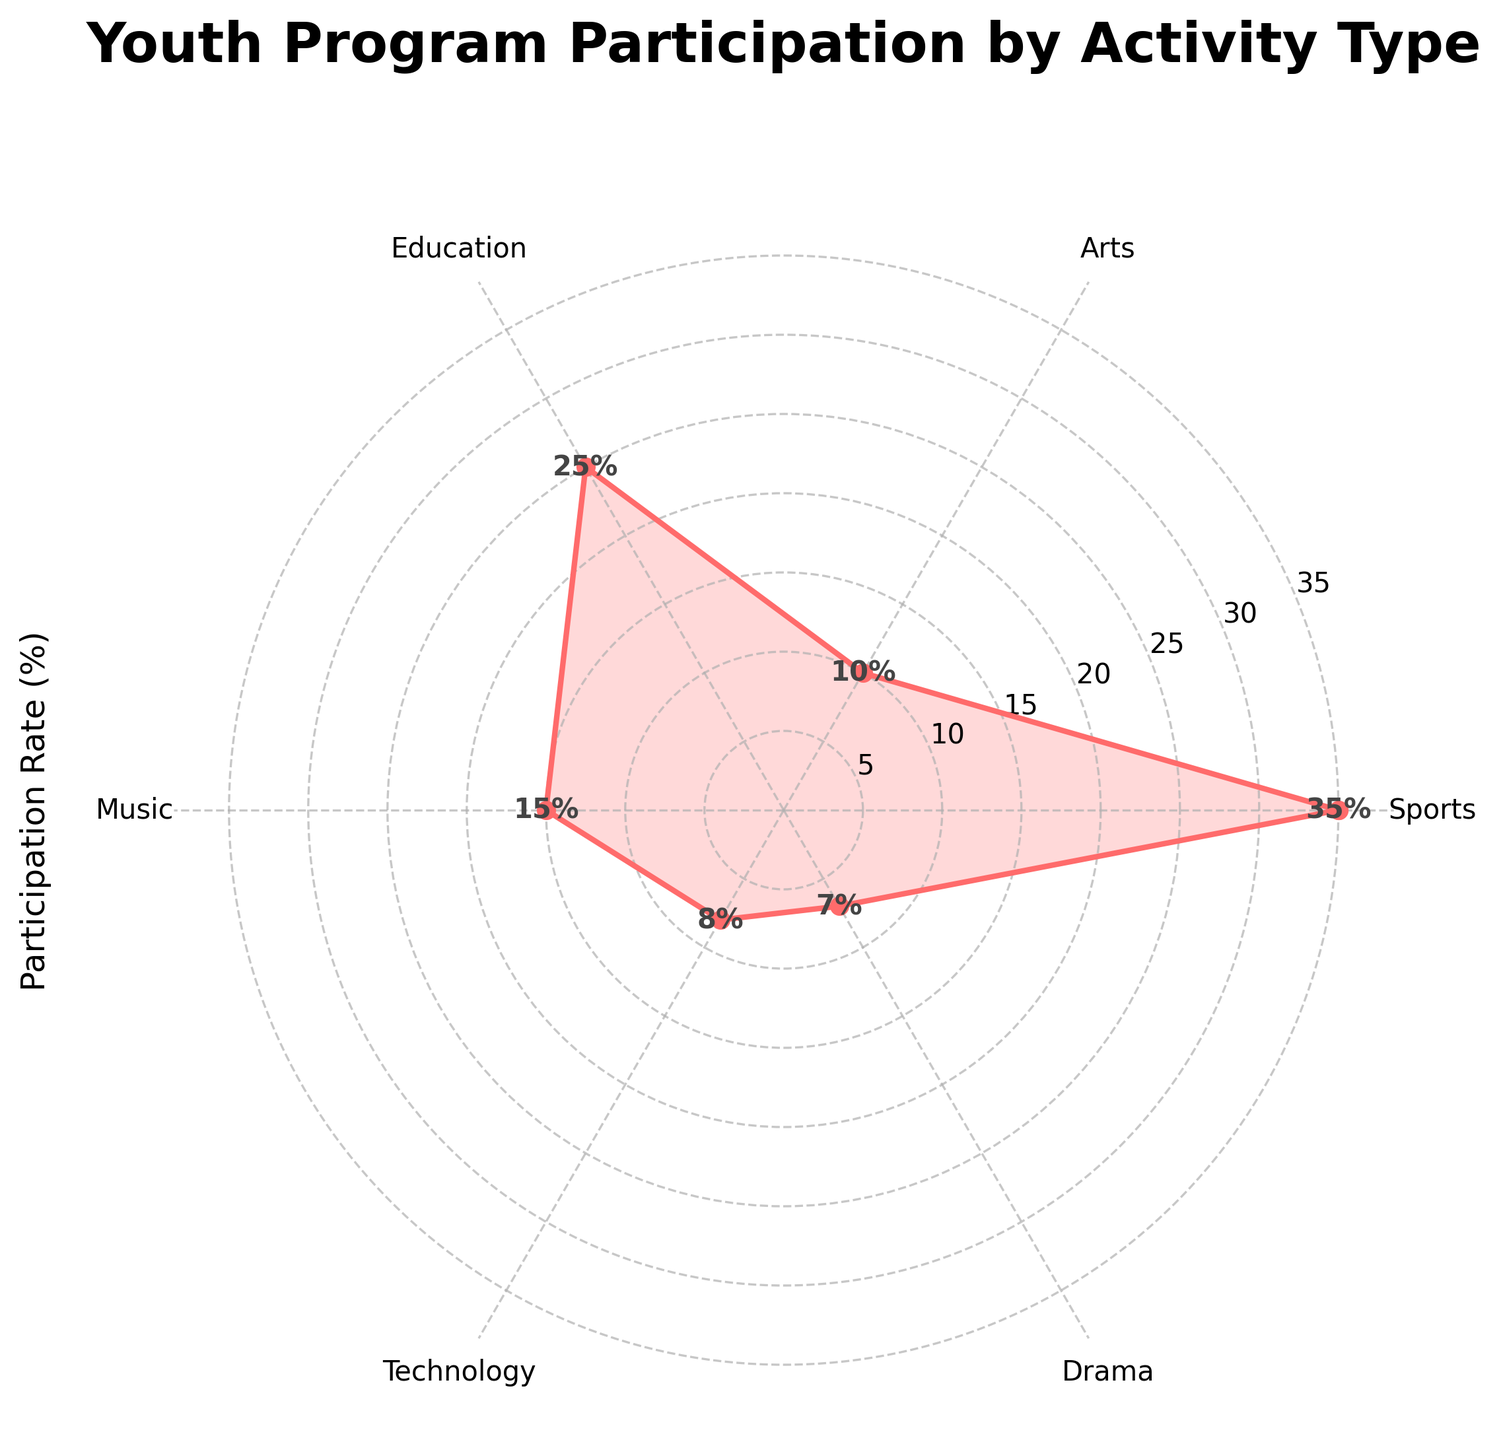What is the title of the plot? The title of the plot is displayed at the top and typically provides a summary of what the chart represents. The plot's title is "Youth Program Participation by Activity Type."
Answer: Youth Program Participation by Activity Type Which activity type has the highest participation rate? The data points on the figure indicate that Sports has the highest participation rate.
Answer: Sports What is the participation rate for Arts? By looking at the labeled data points, you can find that the participation rate for Arts is 10%.
Answer: 10% How many activities have a participation rate above 20%? By examining the data points, you can see that only two activities (Sports and Education) have participation rates above 20%.
Answer: 2 Which activity has the lowest participation rate and what is it? The lowest point on the chart represents the activity with the lowest participation rate, which is Drama with a rate of 7%.
Answer: Drama, 7% How does the participation rate for Music compare to Technology? Comparing the data points, Music has a higher participation rate (15%) than Technology (8%).
Answer: Music has a higher rate What is the difference in participation rates between Education and Arts? The participation rate for Education is 25% and for Arts is 10%. The difference is calculated by subtracting 10% from 25%.
Answer: 15% If you sum up the participation rates for Drama and Technology, what do you get? Summing up the rates for Drama (7%) and Technology (8%) gives 7% + 8%.
Answer: 15% What is the average participation rate for all activities shown? Adding the rates (35 + 10 + 25 + 15 + 8 + 7) and dividing by the number of activities (6) gives the average.
Answer: 16.7% Is the participation rate for Arts more or less than half the rate for Sports? The participation rate for Sports is 35%, so half of that is 17.5%. Arts has a participation rate of 10%, which is less than half of 35%.
Answer: Less 